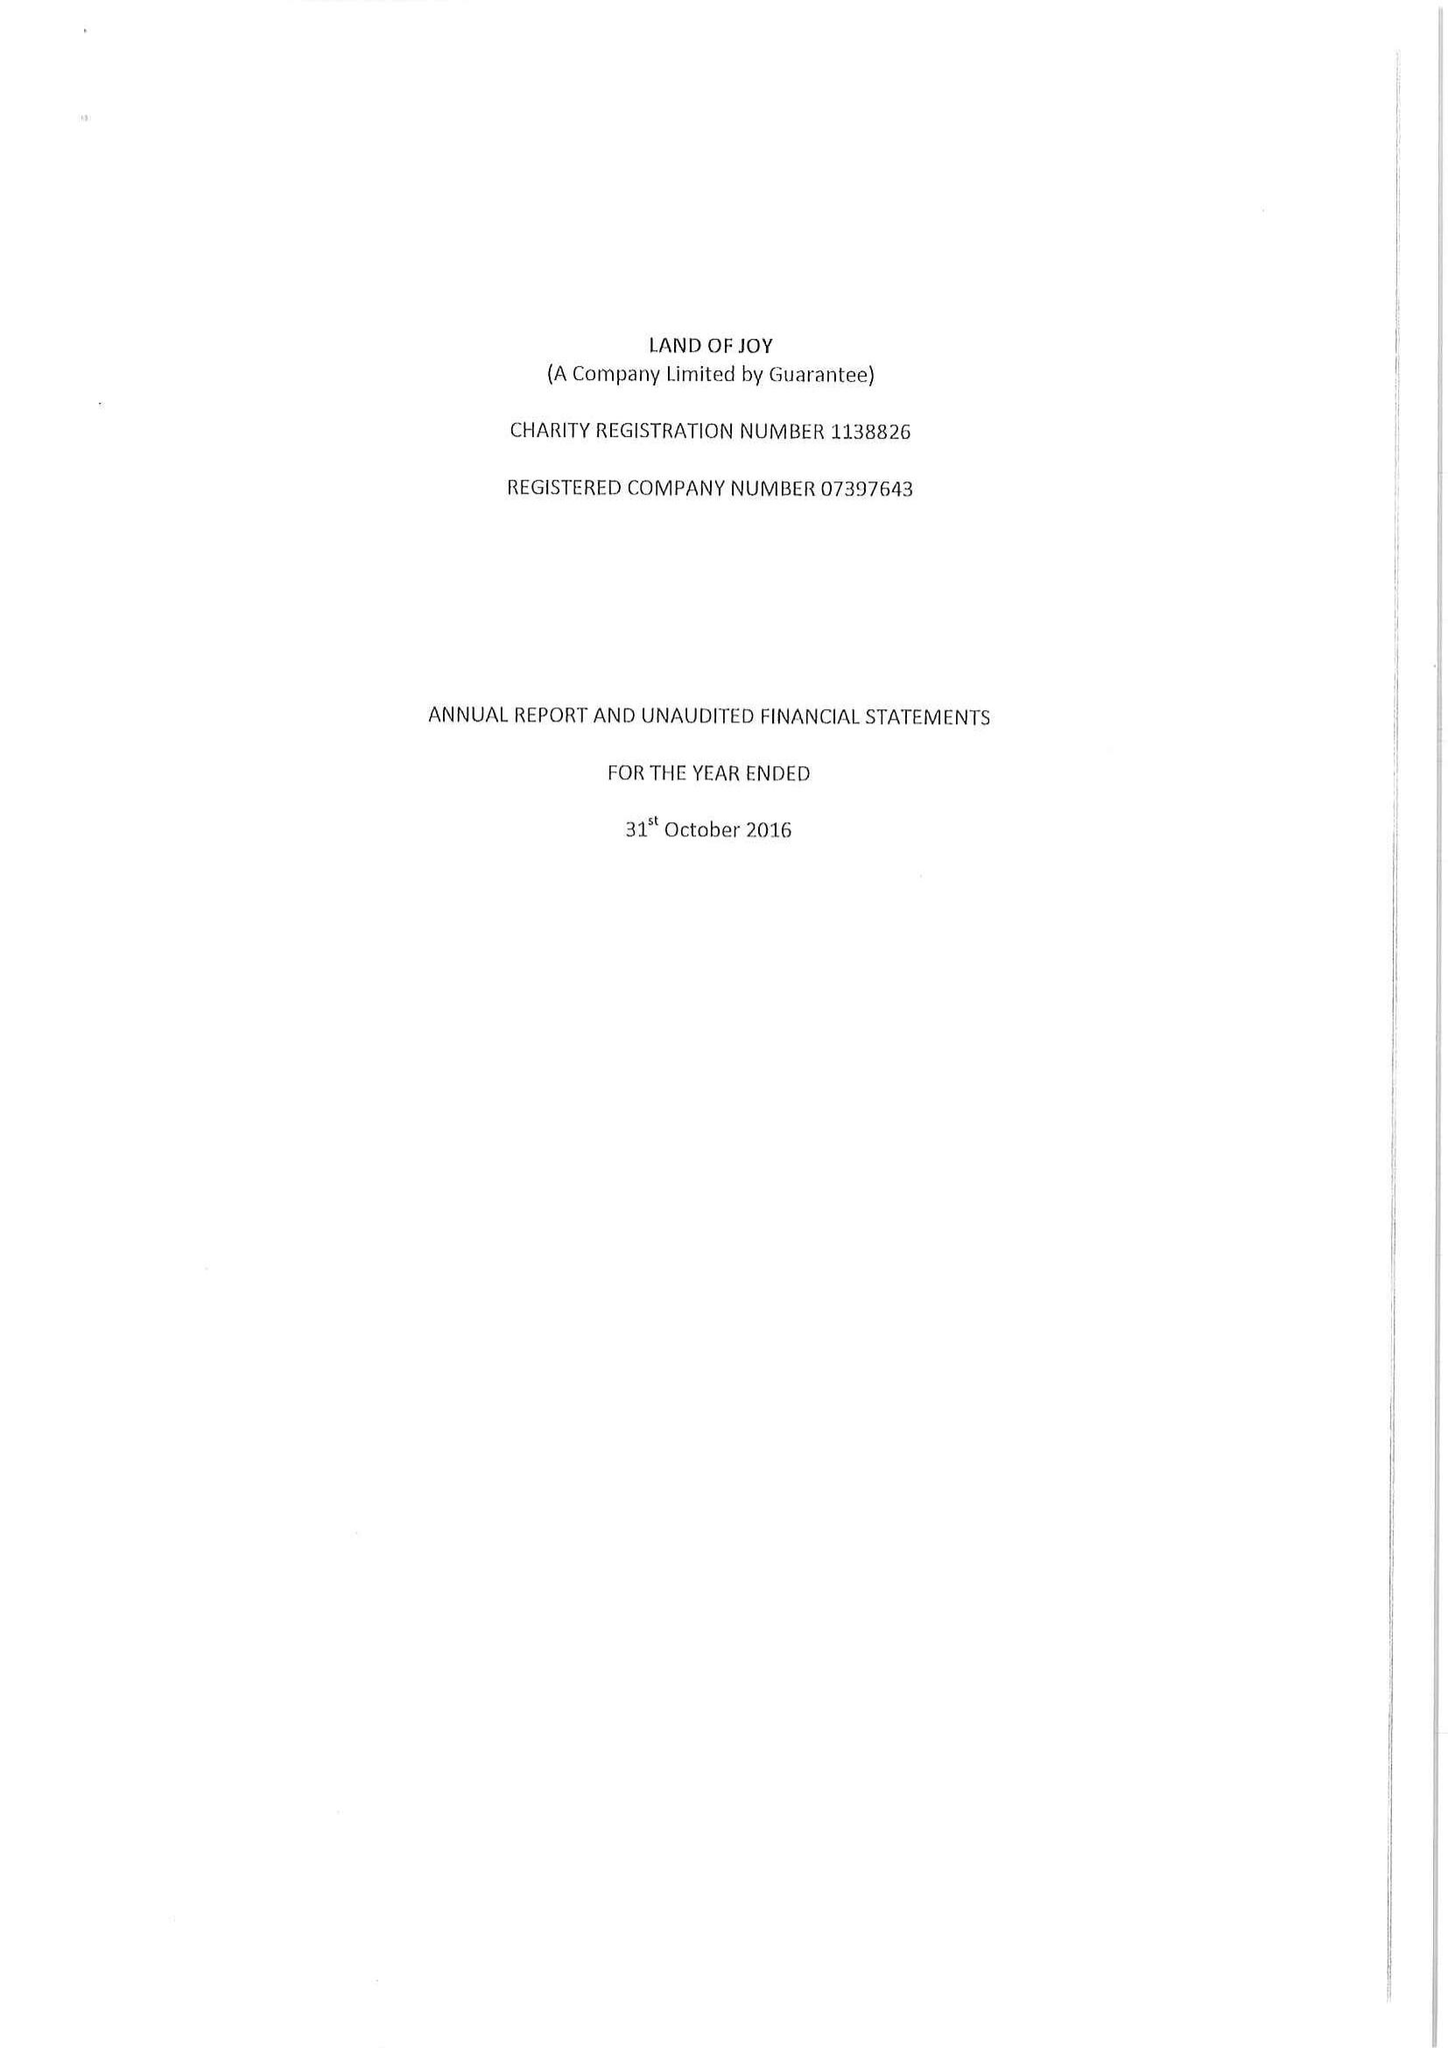What is the value for the address__post_town?
Answer the question using a single word or phrase. HEXHAM 